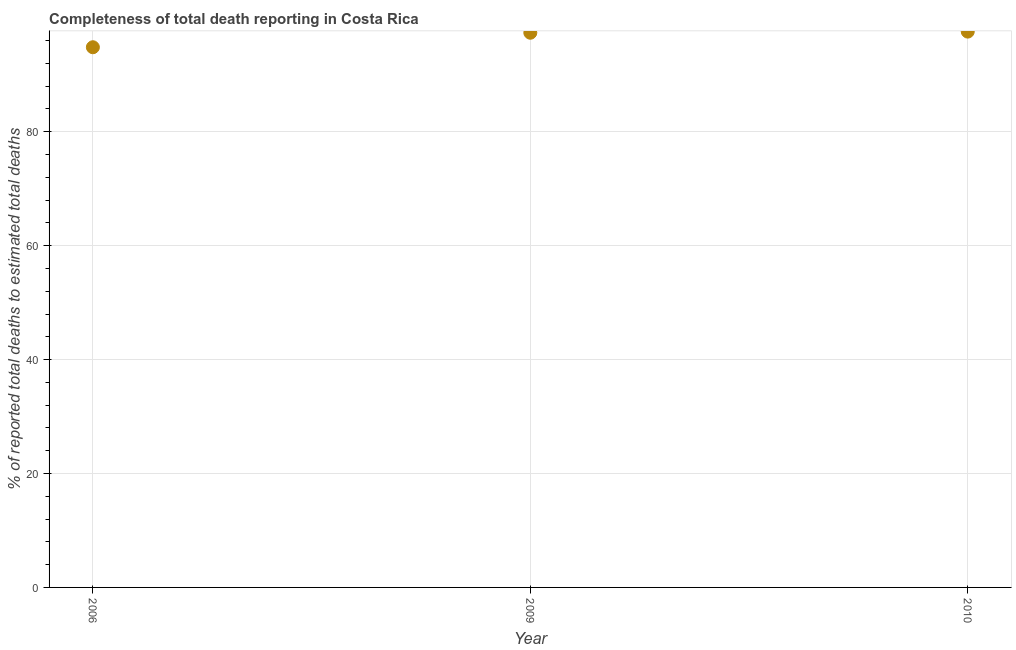What is the completeness of total death reports in 2006?
Provide a short and direct response. 94.84. Across all years, what is the maximum completeness of total death reports?
Keep it short and to the point. 97.58. Across all years, what is the minimum completeness of total death reports?
Your answer should be very brief. 94.84. In which year was the completeness of total death reports minimum?
Give a very brief answer. 2006. What is the sum of the completeness of total death reports?
Offer a terse response. 289.8. What is the difference between the completeness of total death reports in 2009 and 2010?
Make the answer very short. -0.2. What is the average completeness of total death reports per year?
Offer a terse response. 96.6. What is the median completeness of total death reports?
Make the answer very short. 97.38. Do a majority of the years between 2009 and 2006 (inclusive) have completeness of total death reports greater than 28 %?
Your answer should be compact. No. What is the ratio of the completeness of total death reports in 2006 to that in 2009?
Offer a terse response. 0.97. What is the difference between the highest and the second highest completeness of total death reports?
Your response must be concise. 0.2. Is the sum of the completeness of total death reports in 2006 and 2010 greater than the maximum completeness of total death reports across all years?
Keep it short and to the point. Yes. What is the difference between the highest and the lowest completeness of total death reports?
Your answer should be compact. 2.74. In how many years, is the completeness of total death reports greater than the average completeness of total death reports taken over all years?
Offer a terse response. 2. How many dotlines are there?
Your answer should be very brief. 1. What is the difference between two consecutive major ticks on the Y-axis?
Provide a succinct answer. 20. Does the graph contain grids?
Offer a terse response. Yes. What is the title of the graph?
Your response must be concise. Completeness of total death reporting in Costa Rica. What is the label or title of the Y-axis?
Make the answer very short. % of reported total deaths to estimated total deaths. What is the % of reported total deaths to estimated total deaths in 2006?
Your answer should be compact. 94.84. What is the % of reported total deaths to estimated total deaths in 2009?
Your answer should be compact. 97.38. What is the % of reported total deaths to estimated total deaths in 2010?
Provide a succinct answer. 97.58. What is the difference between the % of reported total deaths to estimated total deaths in 2006 and 2009?
Your answer should be compact. -2.55. What is the difference between the % of reported total deaths to estimated total deaths in 2006 and 2010?
Provide a succinct answer. -2.74. What is the difference between the % of reported total deaths to estimated total deaths in 2009 and 2010?
Make the answer very short. -0.2. What is the ratio of the % of reported total deaths to estimated total deaths in 2006 to that in 2009?
Keep it short and to the point. 0.97. What is the ratio of the % of reported total deaths to estimated total deaths in 2006 to that in 2010?
Keep it short and to the point. 0.97. 